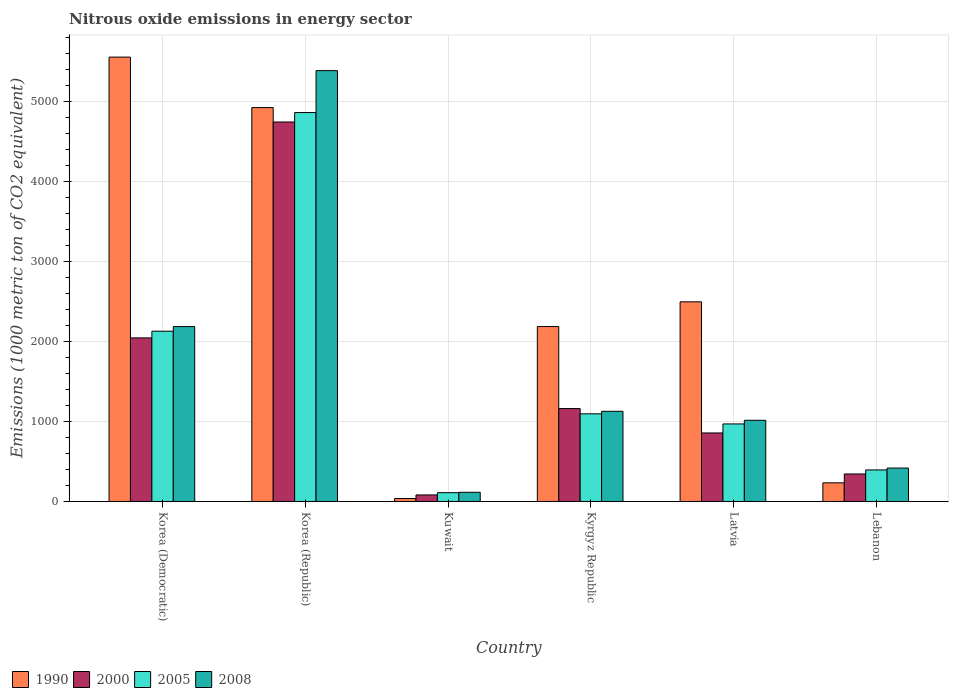How many groups of bars are there?
Your answer should be compact. 6. Are the number of bars per tick equal to the number of legend labels?
Offer a terse response. Yes. Are the number of bars on each tick of the X-axis equal?
Offer a very short reply. Yes. How many bars are there on the 1st tick from the right?
Give a very brief answer. 4. What is the label of the 4th group of bars from the left?
Your answer should be compact. Kyrgyz Republic. In how many cases, is the number of bars for a given country not equal to the number of legend labels?
Your answer should be compact. 0. What is the amount of nitrous oxide emitted in 1990 in Kyrgyz Republic?
Keep it short and to the point. 2188.3. Across all countries, what is the maximum amount of nitrous oxide emitted in 2008?
Offer a terse response. 5389.6. Across all countries, what is the minimum amount of nitrous oxide emitted in 2008?
Provide a short and direct response. 114.9. In which country was the amount of nitrous oxide emitted in 1990 maximum?
Make the answer very short. Korea (Democratic). In which country was the amount of nitrous oxide emitted in 2008 minimum?
Offer a very short reply. Kuwait. What is the total amount of nitrous oxide emitted in 2008 in the graph?
Offer a terse response. 1.03e+04. What is the difference between the amount of nitrous oxide emitted in 2000 in Latvia and that in Lebanon?
Provide a succinct answer. 512.9. What is the difference between the amount of nitrous oxide emitted in 2005 in Korea (Democratic) and the amount of nitrous oxide emitted in 1990 in Lebanon?
Provide a succinct answer. 1896.9. What is the average amount of nitrous oxide emitted in 1990 per country?
Ensure brevity in your answer.  2573.62. What is the difference between the amount of nitrous oxide emitted of/in 1990 and amount of nitrous oxide emitted of/in 2005 in Korea (Democratic)?
Offer a terse response. 3428.6. In how many countries, is the amount of nitrous oxide emitted in 2000 greater than 5400 1000 metric ton?
Provide a succinct answer. 0. What is the ratio of the amount of nitrous oxide emitted in 2000 in Kuwait to that in Lebanon?
Your answer should be very brief. 0.24. Is the difference between the amount of nitrous oxide emitted in 1990 in Kuwait and Kyrgyz Republic greater than the difference between the amount of nitrous oxide emitted in 2005 in Kuwait and Kyrgyz Republic?
Your answer should be very brief. No. What is the difference between the highest and the second highest amount of nitrous oxide emitted in 2005?
Your answer should be very brief. -3768.6. What is the difference between the highest and the lowest amount of nitrous oxide emitted in 2000?
Provide a succinct answer. 4664.9. In how many countries, is the amount of nitrous oxide emitted in 2000 greater than the average amount of nitrous oxide emitted in 2000 taken over all countries?
Your response must be concise. 2. Is it the case that in every country, the sum of the amount of nitrous oxide emitted in 1990 and amount of nitrous oxide emitted in 2000 is greater than the sum of amount of nitrous oxide emitted in 2005 and amount of nitrous oxide emitted in 2008?
Keep it short and to the point. No. What does the 1st bar from the left in Latvia represents?
Your response must be concise. 1990. What does the 3rd bar from the right in Latvia represents?
Offer a terse response. 2000. How many bars are there?
Offer a terse response. 24. How many countries are there in the graph?
Offer a terse response. 6. Does the graph contain any zero values?
Your response must be concise. No. Does the graph contain grids?
Make the answer very short. Yes. How are the legend labels stacked?
Make the answer very short. Horizontal. What is the title of the graph?
Your answer should be very brief. Nitrous oxide emissions in energy sector. Does "2011" appear as one of the legend labels in the graph?
Offer a terse response. No. What is the label or title of the Y-axis?
Keep it short and to the point. Emissions (1000 metric ton of CO2 equivalent). What is the Emissions (1000 metric ton of CO2 equivalent) in 1990 in Korea (Democratic)?
Your answer should be very brief. 5558.7. What is the Emissions (1000 metric ton of CO2 equivalent) of 2000 in Korea (Democratic)?
Your answer should be very brief. 2046.4. What is the Emissions (1000 metric ton of CO2 equivalent) in 2005 in Korea (Democratic)?
Your answer should be compact. 2130.1. What is the Emissions (1000 metric ton of CO2 equivalent) of 2008 in Korea (Democratic)?
Provide a short and direct response. 2187.5. What is the Emissions (1000 metric ton of CO2 equivalent) in 1990 in Korea (Republic)?
Make the answer very short. 4927.4. What is the Emissions (1000 metric ton of CO2 equivalent) in 2000 in Korea (Republic)?
Your answer should be very brief. 4746.8. What is the Emissions (1000 metric ton of CO2 equivalent) of 2005 in Korea (Republic)?
Ensure brevity in your answer.  4865. What is the Emissions (1000 metric ton of CO2 equivalent) in 2008 in Korea (Republic)?
Make the answer very short. 5389.6. What is the Emissions (1000 metric ton of CO2 equivalent) of 1990 in Kuwait?
Make the answer very short. 36.7. What is the Emissions (1000 metric ton of CO2 equivalent) in 2000 in Kuwait?
Ensure brevity in your answer.  81.9. What is the Emissions (1000 metric ton of CO2 equivalent) of 2005 in Kuwait?
Keep it short and to the point. 109.8. What is the Emissions (1000 metric ton of CO2 equivalent) in 2008 in Kuwait?
Offer a very short reply. 114.9. What is the Emissions (1000 metric ton of CO2 equivalent) in 1990 in Kyrgyz Republic?
Provide a short and direct response. 2188.3. What is the Emissions (1000 metric ton of CO2 equivalent) of 2000 in Kyrgyz Republic?
Provide a succinct answer. 1162.4. What is the Emissions (1000 metric ton of CO2 equivalent) in 2005 in Kyrgyz Republic?
Ensure brevity in your answer.  1096.4. What is the Emissions (1000 metric ton of CO2 equivalent) in 2008 in Kyrgyz Republic?
Offer a terse response. 1127.9. What is the Emissions (1000 metric ton of CO2 equivalent) of 1990 in Latvia?
Ensure brevity in your answer.  2497.4. What is the Emissions (1000 metric ton of CO2 equivalent) of 2000 in Latvia?
Your response must be concise. 857.1. What is the Emissions (1000 metric ton of CO2 equivalent) of 2005 in Latvia?
Ensure brevity in your answer.  970. What is the Emissions (1000 metric ton of CO2 equivalent) in 2008 in Latvia?
Your answer should be very brief. 1015.5. What is the Emissions (1000 metric ton of CO2 equivalent) in 1990 in Lebanon?
Provide a short and direct response. 233.2. What is the Emissions (1000 metric ton of CO2 equivalent) in 2000 in Lebanon?
Keep it short and to the point. 344.2. What is the Emissions (1000 metric ton of CO2 equivalent) of 2005 in Lebanon?
Provide a succinct answer. 394.7. What is the Emissions (1000 metric ton of CO2 equivalent) in 2008 in Lebanon?
Ensure brevity in your answer.  418.1. Across all countries, what is the maximum Emissions (1000 metric ton of CO2 equivalent) in 1990?
Provide a short and direct response. 5558.7. Across all countries, what is the maximum Emissions (1000 metric ton of CO2 equivalent) of 2000?
Your answer should be very brief. 4746.8. Across all countries, what is the maximum Emissions (1000 metric ton of CO2 equivalent) of 2005?
Make the answer very short. 4865. Across all countries, what is the maximum Emissions (1000 metric ton of CO2 equivalent) in 2008?
Your answer should be compact. 5389.6. Across all countries, what is the minimum Emissions (1000 metric ton of CO2 equivalent) in 1990?
Your answer should be very brief. 36.7. Across all countries, what is the minimum Emissions (1000 metric ton of CO2 equivalent) of 2000?
Provide a succinct answer. 81.9. Across all countries, what is the minimum Emissions (1000 metric ton of CO2 equivalent) of 2005?
Give a very brief answer. 109.8. Across all countries, what is the minimum Emissions (1000 metric ton of CO2 equivalent) of 2008?
Your answer should be compact. 114.9. What is the total Emissions (1000 metric ton of CO2 equivalent) of 1990 in the graph?
Make the answer very short. 1.54e+04. What is the total Emissions (1000 metric ton of CO2 equivalent) of 2000 in the graph?
Keep it short and to the point. 9238.8. What is the total Emissions (1000 metric ton of CO2 equivalent) in 2005 in the graph?
Keep it short and to the point. 9566. What is the total Emissions (1000 metric ton of CO2 equivalent) of 2008 in the graph?
Offer a very short reply. 1.03e+04. What is the difference between the Emissions (1000 metric ton of CO2 equivalent) in 1990 in Korea (Democratic) and that in Korea (Republic)?
Make the answer very short. 631.3. What is the difference between the Emissions (1000 metric ton of CO2 equivalent) in 2000 in Korea (Democratic) and that in Korea (Republic)?
Provide a succinct answer. -2700.4. What is the difference between the Emissions (1000 metric ton of CO2 equivalent) of 2005 in Korea (Democratic) and that in Korea (Republic)?
Your response must be concise. -2734.9. What is the difference between the Emissions (1000 metric ton of CO2 equivalent) of 2008 in Korea (Democratic) and that in Korea (Republic)?
Ensure brevity in your answer.  -3202.1. What is the difference between the Emissions (1000 metric ton of CO2 equivalent) of 1990 in Korea (Democratic) and that in Kuwait?
Give a very brief answer. 5522. What is the difference between the Emissions (1000 metric ton of CO2 equivalent) in 2000 in Korea (Democratic) and that in Kuwait?
Your answer should be compact. 1964.5. What is the difference between the Emissions (1000 metric ton of CO2 equivalent) of 2005 in Korea (Democratic) and that in Kuwait?
Ensure brevity in your answer.  2020.3. What is the difference between the Emissions (1000 metric ton of CO2 equivalent) of 2008 in Korea (Democratic) and that in Kuwait?
Your response must be concise. 2072.6. What is the difference between the Emissions (1000 metric ton of CO2 equivalent) in 1990 in Korea (Democratic) and that in Kyrgyz Republic?
Provide a short and direct response. 3370.4. What is the difference between the Emissions (1000 metric ton of CO2 equivalent) of 2000 in Korea (Democratic) and that in Kyrgyz Republic?
Provide a short and direct response. 884. What is the difference between the Emissions (1000 metric ton of CO2 equivalent) of 2005 in Korea (Democratic) and that in Kyrgyz Republic?
Provide a succinct answer. 1033.7. What is the difference between the Emissions (1000 metric ton of CO2 equivalent) in 2008 in Korea (Democratic) and that in Kyrgyz Republic?
Keep it short and to the point. 1059.6. What is the difference between the Emissions (1000 metric ton of CO2 equivalent) in 1990 in Korea (Democratic) and that in Latvia?
Provide a short and direct response. 3061.3. What is the difference between the Emissions (1000 metric ton of CO2 equivalent) in 2000 in Korea (Democratic) and that in Latvia?
Provide a short and direct response. 1189.3. What is the difference between the Emissions (1000 metric ton of CO2 equivalent) of 2005 in Korea (Democratic) and that in Latvia?
Give a very brief answer. 1160.1. What is the difference between the Emissions (1000 metric ton of CO2 equivalent) of 2008 in Korea (Democratic) and that in Latvia?
Keep it short and to the point. 1172. What is the difference between the Emissions (1000 metric ton of CO2 equivalent) of 1990 in Korea (Democratic) and that in Lebanon?
Your answer should be very brief. 5325.5. What is the difference between the Emissions (1000 metric ton of CO2 equivalent) of 2000 in Korea (Democratic) and that in Lebanon?
Your answer should be very brief. 1702.2. What is the difference between the Emissions (1000 metric ton of CO2 equivalent) of 2005 in Korea (Democratic) and that in Lebanon?
Your answer should be compact. 1735.4. What is the difference between the Emissions (1000 metric ton of CO2 equivalent) in 2008 in Korea (Democratic) and that in Lebanon?
Keep it short and to the point. 1769.4. What is the difference between the Emissions (1000 metric ton of CO2 equivalent) of 1990 in Korea (Republic) and that in Kuwait?
Offer a terse response. 4890.7. What is the difference between the Emissions (1000 metric ton of CO2 equivalent) in 2000 in Korea (Republic) and that in Kuwait?
Offer a very short reply. 4664.9. What is the difference between the Emissions (1000 metric ton of CO2 equivalent) of 2005 in Korea (Republic) and that in Kuwait?
Make the answer very short. 4755.2. What is the difference between the Emissions (1000 metric ton of CO2 equivalent) in 2008 in Korea (Republic) and that in Kuwait?
Offer a terse response. 5274.7. What is the difference between the Emissions (1000 metric ton of CO2 equivalent) of 1990 in Korea (Republic) and that in Kyrgyz Republic?
Provide a short and direct response. 2739.1. What is the difference between the Emissions (1000 metric ton of CO2 equivalent) of 2000 in Korea (Republic) and that in Kyrgyz Republic?
Keep it short and to the point. 3584.4. What is the difference between the Emissions (1000 metric ton of CO2 equivalent) of 2005 in Korea (Republic) and that in Kyrgyz Republic?
Keep it short and to the point. 3768.6. What is the difference between the Emissions (1000 metric ton of CO2 equivalent) of 2008 in Korea (Republic) and that in Kyrgyz Republic?
Offer a terse response. 4261.7. What is the difference between the Emissions (1000 metric ton of CO2 equivalent) in 1990 in Korea (Republic) and that in Latvia?
Keep it short and to the point. 2430. What is the difference between the Emissions (1000 metric ton of CO2 equivalent) of 2000 in Korea (Republic) and that in Latvia?
Your answer should be compact. 3889.7. What is the difference between the Emissions (1000 metric ton of CO2 equivalent) of 2005 in Korea (Republic) and that in Latvia?
Your answer should be very brief. 3895. What is the difference between the Emissions (1000 metric ton of CO2 equivalent) of 2008 in Korea (Republic) and that in Latvia?
Give a very brief answer. 4374.1. What is the difference between the Emissions (1000 metric ton of CO2 equivalent) in 1990 in Korea (Republic) and that in Lebanon?
Provide a short and direct response. 4694.2. What is the difference between the Emissions (1000 metric ton of CO2 equivalent) of 2000 in Korea (Republic) and that in Lebanon?
Ensure brevity in your answer.  4402.6. What is the difference between the Emissions (1000 metric ton of CO2 equivalent) of 2005 in Korea (Republic) and that in Lebanon?
Keep it short and to the point. 4470.3. What is the difference between the Emissions (1000 metric ton of CO2 equivalent) of 2008 in Korea (Republic) and that in Lebanon?
Your response must be concise. 4971.5. What is the difference between the Emissions (1000 metric ton of CO2 equivalent) in 1990 in Kuwait and that in Kyrgyz Republic?
Your response must be concise. -2151.6. What is the difference between the Emissions (1000 metric ton of CO2 equivalent) in 2000 in Kuwait and that in Kyrgyz Republic?
Provide a short and direct response. -1080.5. What is the difference between the Emissions (1000 metric ton of CO2 equivalent) of 2005 in Kuwait and that in Kyrgyz Republic?
Keep it short and to the point. -986.6. What is the difference between the Emissions (1000 metric ton of CO2 equivalent) of 2008 in Kuwait and that in Kyrgyz Republic?
Your answer should be very brief. -1013. What is the difference between the Emissions (1000 metric ton of CO2 equivalent) in 1990 in Kuwait and that in Latvia?
Ensure brevity in your answer.  -2460.7. What is the difference between the Emissions (1000 metric ton of CO2 equivalent) in 2000 in Kuwait and that in Latvia?
Ensure brevity in your answer.  -775.2. What is the difference between the Emissions (1000 metric ton of CO2 equivalent) in 2005 in Kuwait and that in Latvia?
Give a very brief answer. -860.2. What is the difference between the Emissions (1000 metric ton of CO2 equivalent) of 2008 in Kuwait and that in Latvia?
Offer a very short reply. -900.6. What is the difference between the Emissions (1000 metric ton of CO2 equivalent) in 1990 in Kuwait and that in Lebanon?
Offer a terse response. -196.5. What is the difference between the Emissions (1000 metric ton of CO2 equivalent) of 2000 in Kuwait and that in Lebanon?
Ensure brevity in your answer.  -262.3. What is the difference between the Emissions (1000 metric ton of CO2 equivalent) of 2005 in Kuwait and that in Lebanon?
Ensure brevity in your answer.  -284.9. What is the difference between the Emissions (1000 metric ton of CO2 equivalent) in 2008 in Kuwait and that in Lebanon?
Your answer should be compact. -303.2. What is the difference between the Emissions (1000 metric ton of CO2 equivalent) of 1990 in Kyrgyz Republic and that in Latvia?
Ensure brevity in your answer.  -309.1. What is the difference between the Emissions (1000 metric ton of CO2 equivalent) in 2000 in Kyrgyz Republic and that in Latvia?
Ensure brevity in your answer.  305.3. What is the difference between the Emissions (1000 metric ton of CO2 equivalent) in 2005 in Kyrgyz Republic and that in Latvia?
Give a very brief answer. 126.4. What is the difference between the Emissions (1000 metric ton of CO2 equivalent) of 2008 in Kyrgyz Republic and that in Latvia?
Make the answer very short. 112.4. What is the difference between the Emissions (1000 metric ton of CO2 equivalent) in 1990 in Kyrgyz Republic and that in Lebanon?
Give a very brief answer. 1955.1. What is the difference between the Emissions (1000 metric ton of CO2 equivalent) in 2000 in Kyrgyz Republic and that in Lebanon?
Make the answer very short. 818.2. What is the difference between the Emissions (1000 metric ton of CO2 equivalent) of 2005 in Kyrgyz Republic and that in Lebanon?
Keep it short and to the point. 701.7. What is the difference between the Emissions (1000 metric ton of CO2 equivalent) in 2008 in Kyrgyz Republic and that in Lebanon?
Give a very brief answer. 709.8. What is the difference between the Emissions (1000 metric ton of CO2 equivalent) of 1990 in Latvia and that in Lebanon?
Provide a succinct answer. 2264.2. What is the difference between the Emissions (1000 metric ton of CO2 equivalent) of 2000 in Latvia and that in Lebanon?
Ensure brevity in your answer.  512.9. What is the difference between the Emissions (1000 metric ton of CO2 equivalent) of 2005 in Latvia and that in Lebanon?
Offer a very short reply. 575.3. What is the difference between the Emissions (1000 metric ton of CO2 equivalent) of 2008 in Latvia and that in Lebanon?
Provide a succinct answer. 597.4. What is the difference between the Emissions (1000 metric ton of CO2 equivalent) of 1990 in Korea (Democratic) and the Emissions (1000 metric ton of CO2 equivalent) of 2000 in Korea (Republic)?
Give a very brief answer. 811.9. What is the difference between the Emissions (1000 metric ton of CO2 equivalent) in 1990 in Korea (Democratic) and the Emissions (1000 metric ton of CO2 equivalent) in 2005 in Korea (Republic)?
Provide a short and direct response. 693.7. What is the difference between the Emissions (1000 metric ton of CO2 equivalent) of 1990 in Korea (Democratic) and the Emissions (1000 metric ton of CO2 equivalent) of 2008 in Korea (Republic)?
Provide a succinct answer. 169.1. What is the difference between the Emissions (1000 metric ton of CO2 equivalent) of 2000 in Korea (Democratic) and the Emissions (1000 metric ton of CO2 equivalent) of 2005 in Korea (Republic)?
Offer a terse response. -2818.6. What is the difference between the Emissions (1000 metric ton of CO2 equivalent) in 2000 in Korea (Democratic) and the Emissions (1000 metric ton of CO2 equivalent) in 2008 in Korea (Republic)?
Offer a very short reply. -3343.2. What is the difference between the Emissions (1000 metric ton of CO2 equivalent) of 2005 in Korea (Democratic) and the Emissions (1000 metric ton of CO2 equivalent) of 2008 in Korea (Republic)?
Offer a terse response. -3259.5. What is the difference between the Emissions (1000 metric ton of CO2 equivalent) of 1990 in Korea (Democratic) and the Emissions (1000 metric ton of CO2 equivalent) of 2000 in Kuwait?
Keep it short and to the point. 5476.8. What is the difference between the Emissions (1000 metric ton of CO2 equivalent) in 1990 in Korea (Democratic) and the Emissions (1000 metric ton of CO2 equivalent) in 2005 in Kuwait?
Offer a terse response. 5448.9. What is the difference between the Emissions (1000 metric ton of CO2 equivalent) in 1990 in Korea (Democratic) and the Emissions (1000 metric ton of CO2 equivalent) in 2008 in Kuwait?
Ensure brevity in your answer.  5443.8. What is the difference between the Emissions (1000 metric ton of CO2 equivalent) of 2000 in Korea (Democratic) and the Emissions (1000 metric ton of CO2 equivalent) of 2005 in Kuwait?
Provide a succinct answer. 1936.6. What is the difference between the Emissions (1000 metric ton of CO2 equivalent) of 2000 in Korea (Democratic) and the Emissions (1000 metric ton of CO2 equivalent) of 2008 in Kuwait?
Your answer should be compact. 1931.5. What is the difference between the Emissions (1000 metric ton of CO2 equivalent) in 2005 in Korea (Democratic) and the Emissions (1000 metric ton of CO2 equivalent) in 2008 in Kuwait?
Your answer should be compact. 2015.2. What is the difference between the Emissions (1000 metric ton of CO2 equivalent) in 1990 in Korea (Democratic) and the Emissions (1000 metric ton of CO2 equivalent) in 2000 in Kyrgyz Republic?
Offer a terse response. 4396.3. What is the difference between the Emissions (1000 metric ton of CO2 equivalent) of 1990 in Korea (Democratic) and the Emissions (1000 metric ton of CO2 equivalent) of 2005 in Kyrgyz Republic?
Provide a succinct answer. 4462.3. What is the difference between the Emissions (1000 metric ton of CO2 equivalent) in 1990 in Korea (Democratic) and the Emissions (1000 metric ton of CO2 equivalent) in 2008 in Kyrgyz Republic?
Your answer should be very brief. 4430.8. What is the difference between the Emissions (1000 metric ton of CO2 equivalent) in 2000 in Korea (Democratic) and the Emissions (1000 metric ton of CO2 equivalent) in 2005 in Kyrgyz Republic?
Your answer should be compact. 950. What is the difference between the Emissions (1000 metric ton of CO2 equivalent) in 2000 in Korea (Democratic) and the Emissions (1000 metric ton of CO2 equivalent) in 2008 in Kyrgyz Republic?
Provide a succinct answer. 918.5. What is the difference between the Emissions (1000 metric ton of CO2 equivalent) of 2005 in Korea (Democratic) and the Emissions (1000 metric ton of CO2 equivalent) of 2008 in Kyrgyz Republic?
Ensure brevity in your answer.  1002.2. What is the difference between the Emissions (1000 metric ton of CO2 equivalent) in 1990 in Korea (Democratic) and the Emissions (1000 metric ton of CO2 equivalent) in 2000 in Latvia?
Provide a succinct answer. 4701.6. What is the difference between the Emissions (1000 metric ton of CO2 equivalent) in 1990 in Korea (Democratic) and the Emissions (1000 metric ton of CO2 equivalent) in 2005 in Latvia?
Your response must be concise. 4588.7. What is the difference between the Emissions (1000 metric ton of CO2 equivalent) of 1990 in Korea (Democratic) and the Emissions (1000 metric ton of CO2 equivalent) of 2008 in Latvia?
Offer a terse response. 4543.2. What is the difference between the Emissions (1000 metric ton of CO2 equivalent) of 2000 in Korea (Democratic) and the Emissions (1000 metric ton of CO2 equivalent) of 2005 in Latvia?
Give a very brief answer. 1076.4. What is the difference between the Emissions (1000 metric ton of CO2 equivalent) of 2000 in Korea (Democratic) and the Emissions (1000 metric ton of CO2 equivalent) of 2008 in Latvia?
Keep it short and to the point. 1030.9. What is the difference between the Emissions (1000 metric ton of CO2 equivalent) of 2005 in Korea (Democratic) and the Emissions (1000 metric ton of CO2 equivalent) of 2008 in Latvia?
Offer a very short reply. 1114.6. What is the difference between the Emissions (1000 metric ton of CO2 equivalent) in 1990 in Korea (Democratic) and the Emissions (1000 metric ton of CO2 equivalent) in 2000 in Lebanon?
Ensure brevity in your answer.  5214.5. What is the difference between the Emissions (1000 metric ton of CO2 equivalent) in 1990 in Korea (Democratic) and the Emissions (1000 metric ton of CO2 equivalent) in 2005 in Lebanon?
Give a very brief answer. 5164. What is the difference between the Emissions (1000 metric ton of CO2 equivalent) in 1990 in Korea (Democratic) and the Emissions (1000 metric ton of CO2 equivalent) in 2008 in Lebanon?
Offer a terse response. 5140.6. What is the difference between the Emissions (1000 metric ton of CO2 equivalent) of 2000 in Korea (Democratic) and the Emissions (1000 metric ton of CO2 equivalent) of 2005 in Lebanon?
Offer a terse response. 1651.7. What is the difference between the Emissions (1000 metric ton of CO2 equivalent) of 2000 in Korea (Democratic) and the Emissions (1000 metric ton of CO2 equivalent) of 2008 in Lebanon?
Provide a succinct answer. 1628.3. What is the difference between the Emissions (1000 metric ton of CO2 equivalent) in 2005 in Korea (Democratic) and the Emissions (1000 metric ton of CO2 equivalent) in 2008 in Lebanon?
Give a very brief answer. 1712. What is the difference between the Emissions (1000 metric ton of CO2 equivalent) of 1990 in Korea (Republic) and the Emissions (1000 metric ton of CO2 equivalent) of 2000 in Kuwait?
Your response must be concise. 4845.5. What is the difference between the Emissions (1000 metric ton of CO2 equivalent) in 1990 in Korea (Republic) and the Emissions (1000 metric ton of CO2 equivalent) in 2005 in Kuwait?
Provide a succinct answer. 4817.6. What is the difference between the Emissions (1000 metric ton of CO2 equivalent) in 1990 in Korea (Republic) and the Emissions (1000 metric ton of CO2 equivalent) in 2008 in Kuwait?
Your answer should be very brief. 4812.5. What is the difference between the Emissions (1000 metric ton of CO2 equivalent) in 2000 in Korea (Republic) and the Emissions (1000 metric ton of CO2 equivalent) in 2005 in Kuwait?
Make the answer very short. 4637. What is the difference between the Emissions (1000 metric ton of CO2 equivalent) of 2000 in Korea (Republic) and the Emissions (1000 metric ton of CO2 equivalent) of 2008 in Kuwait?
Make the answer very short. 4631.9. What is the difference between the Emissions (1000 metric ton of CO2 equivalent) of 2005 in Korea (Republic) and the Emissions (1000 metric ton of CO2 equivalent) of 2008 in Kuwait?
Your response must be concise. 4750.1. What is the difference between the Emissions (1000 metric ton of CO2 equivalent) of 1990 in Korea (Republic) and the Emissions (1000 metric ton of CO2 equivalent) of 2000 in Kyrgyz Republic?
Provide a succinct answer. 3765. What is the difference between the Emissions (1000 metric ton of CO2 equivalent) in 1990 in Korea (Republic) and the Emissions (1000 metric ton of CO2 equivalent) in 2005 in Kyrgyz Republic?
Ensure brevity in your answer.  3831. What is the difference between the Emissions (1000 metric ton of CO2 equivalent) of 1990 in Korea (Republic) and the Emissions (1000 metric ton of CO2 equivalent) of 2008 in Kyrgyz Republic?
Give a very brief answer. 3799.5. What is the difference between the Emissions (1000 metric ton of CO2 equivalent) of 2000 in Korea (Republic) and the Emissions (1000 metric ton of CO2 equivalent) of 2005 in Kyrgyz Republic?
Offer a very short reply. 3650.4. What is the difference between the Emissions (1000 metric ton of CO2 equivalent) of 2000 in Korea (Republic) and the Emissions (1000 metric ton of CO2 equivalent) of 2008 in Kyrgyz Republic?
Offer a terse response. 3618.9. What is the difference between the Emissions (1000 metric ton of CO2 equivalent) in 2005 in Korea (Republic) and the Emissions (1000 metric ton of CO2 equivalent) in 2008 in Kyrgyz Republic?
Your answer should be very brief. 3737.1. What is the difference between the Emissions (1000 metric ton of CO2 equivalent) in 1990 in Korea (Republic) and the Emissions (1000 metric ton of CO2 equivalent) in 2000 in Latvia?
Offer a terse response. 4070.3. What is the difference between the Emissions (1000 metric ton of CO2 equivalent) of 1990 in Korea (Republic) and the Emissions (1000 metric ton of CO2 equivalent) of 2005 in Latvia?
Offer a very short reply. 3957.4. What is the difference between the Emissions (1000 metric ton of CO2 equivalent) of 1990 in Korea (Republic) and the Emissions (1000 metric ton of CO2 equivalent) of 2008 in Latvia?
Provide a short and direct response. 3911.9. What is the difference between the Emissions (1000 metric ton of CO2 equivalent) of 2000 in Korea (Republic) and the Emissions (1000 metric ton of CO2 equivalent) of 2005 in Latvia?
Make the answer very short. 3776.8. What is the difference between the Emissions (1000 metric ton of CO2 equivalent) of 2000 in Korea (Republic) and the Emissions (1000 metric ton of CO2 equivalent) of 2008 in Latvia?
Provide a short and direct response. 3731.3. What is the difference between the Emissions (1000 metric ton of CO2 equivalent) in 2005 in Korea (Republic) and the Emissions (1000 metric ton of CO2 equivalent) in 2008 in Latvia?
Make the answer very short. 3849.5. What is the difference between the Emissions (1000 metric ton of CO2 equivalent) of 1990 in Korea (Republic) and the Emissions (1000 metric ton of CO2 equivalent) of 2000 in Lebanon?
Keep it short and to the point. 4583.2. What is the difference between the Emissions (1000 metric ton of CO2 equivalent) of 1990 in Korea (Republic) and the Emissions (1000 metric ton of CO2 equivalent) of 2005 in Lebanon?
Make the answer very short. 4532.7. What is the difference between the Emissions (1000 metric ton of CO2 equivalent) in 1990 in Korea (Republic) and the Emissions (1000 metric ton of CO2 equivalent) in 2008 in Lebanon?
Ensure brevity in your answer.  4509.3. What is the difference between the Emissions (1000 metric ton of CO2 equivalent) of 2000 in Korea (Republic) and the Emissions (1000 metric ton of CO2 equivalent) of 2005 in Lebanon?
Ensure brevity in your answer.  4352.1. What is the difference between the Emissions (1000 metric ton of CO2 equivalent) in 2000 in Korea (Republic) and the Emissions (1000 metric ton of CO2 equivalent) in 2008 in Lebanon?
Your answer should be very brief. 4328.7. What is the difference between the Emissions (1000 metric ton of CO2 equivalent) in 2005 in Korea (Republic) and the Emissions (1000 metric ton of CO2 equivalent) in 2008 in Lebanon?
Your answer should be compact. 4446.9. What is the difference between the Emissions (1000 metric ton of CO2 equivalent) of 1990 in Kuwait and the Emissions (1000 metric ton of CO2 equivalent) of 2000 in Kyrgyz Republic?
Provide a succinct answer. -1125.7. What is the difference between the Emissions (1000 metric ton of CO2 equivalent) in 1990 in Kuwait and the Emissions (1000 metric ton of CO2 equivalent) in 2005 in Kyrgyz Republic?
Offer a very short reply. -1059.7. What is the difference between the Emissions (1000 metric ton of CO2 equivalent) in 1990 in Kuwait and the Emissions (1000 metric ton of CO2 equivalent) in 2008 in Kyrgyz Republic?
Your answer should be compact. -1091.2. What is the difference between the Emissions (1000 metric ton of CO2 equivalent) of 2000 in Kuwait and the Emissions (1000 metric ton of CO2 equivalent) of 2005 in Kyrgyz Republic?
Make the answer very short. -1014.5. What is the difference between the Emissions (1000 metric ton of CO2 equivalent) of 2000 in Kuwait and the Emissions (1000 metric ton of CO2 equivalent) of 2008 in Kyrgyz Republic?
Keep it short and to the point. -1046. What is the difference between the Emissions (1000 metric ton of CO2 equivalent) of 2005 in Kuwait and the Emissions (1000 metric ton of CO2 equivalent) of 2008 in Kyrgyz Republic?
Make the answer very short. -1018.1. What is the difference between the Emissions (1000 metric ton of CO2 equivalent) in 1990 in Kuwait and the Emissions (1000 metric ton of CO2 equivalent) in 2000 in Latvia?
Your answer should be very brief. -820.4. What is the difference between the Emissions (1000 metric ton of CO2 equivalent) in 1990 in Kuwait and the Emissions (1000 metric ton of CO2 equivalent) in 2005 in Latvia?
Your answer should be very brief. -933.3. What is the difference between the Emissions (1000 metric ton of CO2 equivalent) in 1990 in Kuwait and the Emissions (1000 metric ton of CO2 equivalent) in 2008 in Latvia?
Your response must be concise. -978.8. What is the difference between the Emissions (1000 metric ton of CO2 equivalent) of 2000 in Kuwait and the Emissions (1000 metric ton of CO2 equivalent) of 2005 in Latvia?
Provide a short and direct response. -888.1. What is the difference between the Emissions (1000 metric ton of CO2 equivalent) in 2000 in Kuwait and the Emissions (1000 metric ton of CO2 equivalent) in 2008 in Latvia?
Your response must be concise. -933.6. What is the difference between the Emissions (1000 metric ton of CO2 equivalent) of 2005 in Kuwait and the Emissions (1000 metric ton of CO2 equivalent) of 2008 in Latvia?
Make the answer very short. -905.7. What is the difference between the Emissions (1000 metric ton of CO2 equivalent) of 1990 in Kuwait and the Emissions (1000 metric ton of CO2 equivalent) of 2000 in Lebanon?
Keep it short and to the point. -307.5. What is the difference between the Emissions (1000 metric ton of CO2 equivalent) of 1990 in Kuwait and the Emissions (1000 metric ton of CO2 equivalent) of 2005 in Lebanon?
Keep it short and to the point. -358. What is the difference between the Emissions (1000 metric ton of CO2 equivalent) in 1990 in Kuwait and the Emissions (1000 metric ton of CO2 equivalent) in 2008 in Lebanon?
Offer a very short reply. -381.4. What is the difference between the Emissions (1000 metric ton of CO2 equivalent) in 2000 in Kuwait and the Emissions (1000 metric ton of CO2 equivalent) in 2005 in Lebanon?
Make the answer very short. -312.8. What is the difference between the Emissions (1000 metric ton of CO2 equivalent) of 2000 in Kuwait and the Emissions (1000 metric ton of CO2 equivalent) of 2008 in Lebanon?
Provide a succinct answer. -336.2. What is the difference between the Emissions (1000 metric ton of CO2 equivalent) in 2005 in Kuwait and the Emissions (1000 metric ton of CO2 equivalent) in 2008 in Lebanon?
Offer a very short reply. -308.3. What is the difference between the Emissions (1000 metric ton of CO2 equivalent) in 1990 in Kyrgyz Republic and the Emissions (1000 metric ton of CO2 equivalent) in 2000 in Latvia?
Keep it short and to the point. 1331.2. What is the difference between the Emissions (1000 metric ton of CO2 equivalent) in 1990 in Kyrgyz Republic and the Emissions (1000 metric ton of CO2 equivalent) in 2005 in Latvia?
Provide a short and direct response. 1218.3. What is the difference between the Emissions (1000 metric ton of CO2 equivalent) in 1990 in Kyrgyz Republic and the Emissions (1000 metric ton of CO2 equivalent) in 2008 in Latvia?
Offer a very short reply. 1172.8. What is the difference between the Emissions (1000 metric ton of CO2 equivalent) of 2000 in Kyrgyz Republic and the Emissions (1000 metric ton of CO2 equivalent) of 2005 in Latvia?
Ensure brevity in your answer.  192.4. What is the difference between the Emissions (1000 metric ton of CO2 equivalent) of 2000 in Kyrgyz Republic and the Emissions (1000 metric ton of CO2 equivalent) of 2008 in Latvia?
Your answer should be compact. 146.9. What is the difference between the Emissions (1000 metric ton of CO2 equivalent) in 2005 in Kyrgyz Republic and the Emissions (1000 metric ton of CO2 equivalent) in 2008 in Latvia?
Your answer should be compact. 80.9. What is the difference between the Emissions (1000 metric ton of CO2 equivalent) in 1990 in Kyrgyz Republic and the Emissions (1000 metric ton of CO2 equivalent) in 2000 in Lebanon?
Make the answer very short. 1844.1. What is the difference between the Emissions (1000 metric ton of CO2 equivalent) of 1990 in Kyrgyz Republic and the Emissions (1000 metric ton of CO2 equivalent) of 2005 in Lebanon?
Your answer should be very brief. 1793.6. What is the difference between the Emissions (1000 metric ton of CO2 equivalent) of 1990 in Kyrgyz Republic and the Emissions (1000 metric ton of CO2 equivalent) of 2008 in Lebanon?
Provide a short and direct response. 1770.2. What is the difference between the Emissions (1000 metric ton of CO2 equivalent) of 2000 in Kyrgyz Republic and the Emissions (1000 metric ton of CO2 equivalent) of 2005 in Lebanon?
Offer a very short reply. 767.7. What is the difference between the Emissions (1000 metric ton of CO2 equivalent) of 2000 in Kyrgyz Republic and the Emissions (1000 metric ton of CO2 equivalent) of 2008 in Lebanon?
Make the answer very short. 744.3. What is the difference between the Emissions (1000 metric ton of CO2 equivalent) in 2005 in Kyrgyz Republic and the Emissions (1000 metric ton of CO2 equivalent) in 2008 in Lebanon?
Offer a very short reply. 678.3. What is the difference between the Emissions (1000 metric ton of CO2 equivalent) in 1990 in Latvia and the Emissions (1000 metric ton of CO2 equivalent) in 2000 in Lebanon?
Give a very brief answer. 2153.2. What is the difference between the Emissions (1000 metric ton of CO2 equivalent) of 1990 in Latvia and the Emissions (1000 metric ton of CO2 equivalent) of 2005 in Lebanon?
Provide a short and direct response. 2102.7. What is the difference between the Emissions (1000 metric ton of CO2 equivalent) in 1990 in Latvia and the Emissions (1000 metric ton of CO2 equivalent) in 2008 in Lebanon?
Your response must be concise. 2079.3. What is the difference between the Emissions (1000 metric ton of CO2 equivalent) of 2000 in Latvia and the Emissions (1000 metric ton of CO2 equivalent) of 2005 in Lebanon?
Your answer should be very brief. 462.4. What is the difference between the Emissions (1000 metric ton of CO2 equivalent) of 2000 in Latvia and the Emissions (1000 metric ton of CO2 equivalent) of 2008 in Lebanon?
Your response must be concise. 439. What is the difference between the Emissions (1000 metric ton of CO2 equivalent) of 2005 in Latvia and the Emissions (1000 metric ton of CO2 equivalent) of 2008 in Lebanon?
Offer a terse response. 551.9. What is the average Emissions (1000 metric ton of CO2 equivalent) of 1990 per country?
Your answer should be compact. 2573.62. What is the average Emissions (1000 metric ton of CO2 equivalent) of 2000 per country?
Ensure brevity in your answer.  1539.8. What is the average Emissions (1000 metric ton of CO2 equivalent) in 2005 per country?
Ensure brevity in your answer.  1594.33. What is the average Emissions (1000 metric ton of CO2 equivalent) of 2008 per country?
Make the answer very short. 1708.92. What is the difference between the Emissions (1000 metric ton of CO2 equivalent) in 1990 and Emissions (1000 metric ton of CO2 equivalent) in 2000 in Korea (Democratic)?
Your answer should be very brief. 3512.3. What is the difference between the Emissions (1000 metric ton of CO2 equivalent) in 1990 and Emissions (1000 metric ton of CO2 equivalent) in 2005 in Korea (Democratic)?
Your response must be concise. 3428.6. What is the difference between the Emissions (1000 metric ton of CO2 equivalent) of 1990 and Emissions (1000 metric ton of CO2 equivalent) of 2008 in Korea (Democratic)?
Your answer should be very brief. 3371.2. What is the difference between the Emissions (1000 metric ton of CO2 equivalent) of 2000 and Emissions (1000 metric ton of CO2 equivalent) of 2005 in Korea (Democratic)?
Ensure brevity in your answer.  -83.7. What is the difference between the Emissions (1000 metric ton of CO2 equivalent) in 2000 and Emissions (1000 metric ton of CO2 equivalent) in 2008 in Korea (Democratic)?
Offer a terse response. -141.1. What is the difference between the Emissions (1000 metric ton of CO2 equivalent) of 2005 and Emissions (1000 metric ton of CO2 equivalent) of 2008 in Korea (Democratic)?
Your answer should be very brief. -57.4. What is the difference between the Emissions (1000 metric ton of CO2 equivalent) of 1990 and Emissions (1000 metric ton of CO2 equivalent) of 2000 in Korea (Republic)?
Provide a succinct answer. 180.6. What is the difference between the Emissions (1000 metric ton of CO2 equivalent) in 1990 and Emissions (1000 metric ton of CO2 equivalent) in 2005 in Korea (Republic)?
Offer a very short reply. 62.4. What is the difference between the Emissions (1000 metric ton of CO2 equivalent) of 1990 and Emissions (1000 metric ton of CO2 equivalent) of 2008 in Korea (Republic)?
Ensure brevity in your answer.  -462.2. What is the difference between the Emissions (1000 metric ton of CO2 equivalent) of 2000 and Emissions (1000 metric ton of CO2 equivalent) of 2005 in Korea (Republic)?
Your response must be concise. -118.2. What is the difference between the Emissions (1000 metric ton of CO2 equivalent) of 2000 and Emissions (1000 metric ton of CO2 equivalent) of 2008 in Korea (Republic)?
Give a very brief answer. -642.8. What is the difference between the Emissions (1000 metric ton of CO2 equivalent) of 2005 and Emissions (1000 metric ton of CO2 equivalent) of 2008 in Korea (Republic)?
Your response must be concise. -524.6. What is the difference between the Emissions (1000 metric ton of CO2 equivalent) in 1990 and Emissions (1000 metric ton of CO2 equivalent) in 2000 in Kuwait?
Keep it short and to the point. -45.2. What is the difference between the Emissions (1000 metric ton of CO2 equivalent) in 1990 and Emissions (1000 metric ton of CO2 equivalent) in 2005 in Kuwait?
Provide a succinct answer. -73.1. What is the difference between the Emissions (1000 metric ton of CO2 equivalent) of 1990 and Emissions (1000 metric ton of CO2 equivalent) of 2008 in Kuwait?
Offer a terse response. -78.2. What is the difference between the Emissions (1000 metric ton of CO2 equivalent) in 2000 and Emissions (1000 metric ton of CO2 equivalent) in 2005 in Kuwait?
Offer a very short reply. -27.9. What is the difference between the Emissions (1000 metric ton of CO2 equivalent) in 2000 and Emissions (1000 metric ton of CO2 equivalent) in 2008 in Kuwait?
Offer a terse response. -33. What is the difference between the Emissions (1000 metric ton of CO2 equivalent) in 2005 and Emissions (1000 metric ton of CO2 equivalent) in 2008 in Kuwait?
Provide a short and direct response. -5.1. What is the difference between the Emissions (1000 metric ton of CO2 equivalent) of 1990 and Emissions (1000 metric ton of CO2 equivalent) of 2000 in Kyrgyz Republic?
Offer a very short reply. 1025.9. What is the difference between the Emissions (1000 metric ton of CO2 equivalent) of 1990 and Emissions (1000 metric ton of CO2 equivalent) of 2005 in Kyrgyz Republic?
Provide a short and direct response. 1091.9. What is the difference between the Emissions (1000 metric ton of CO2 equivalent) of 1990 and Emissions (1000 metric ton of CO2 equivalent) of 2008 in Kyrgyz Republic?
Ensure brevity in your answer.  1060.4. What is the difference between the Emissions (1000 metric ton of CO2 equivalent) of 2000 and Emissions (1000 metric ton of CO2 equivalent) of 2005 in Kyrgyz Republic?
Offer a very short reply. 66. What is the difference between the Emissions (1000 metric ton of CO2 equivalent) in 2000 and Emissions (1000 metric ton of CO2 equivalent) in 2008 in Kyrgyz Republic?
Provide a succinct answer. 34.5. What is the difference between the Emissions (1000 metric ton of CO2 equivalent) of 2005 and Emissions (1000 metric ton of CO2 equivalent) of 2008 in Kyrgyz Republic?
Ensure brevity in your answer.  -31.5. What is the difference between the Emissions (1000 metric ton of CO2 equivalent) of 1990 and Emissions (1000 metric ton of CO2 equivalent) of 2000 in Latvia?
Give a very brief answer. 1640.3. What is the difference between the Emissions (1000 metric ton of CO2 equivalent) in 1990 and Emissions (1000 metric ton of CO2 equivalent) in 2005 in Latvia?
Your response must be concise. 1527.4. What is the difference between the Emissions (1000 metric ton of CO2 equivalent) of 1990 and Emissions (1000 metric ton of CO2 equivalent) of 2008 in Latvia?
Your answer should be compact. 1481.9. What is the difference between the Emissions (1000 metric ton of CO2 equivalent) in 2000 and Emissions (1000 metric ton of CO2 equivalent) in 2005 in Latvia?
Make the answer very short. -112.9. What is the difference between the Emissions (1000 metric ton of CO2 equivalent) in 2000 and Emissions (1000 metric ton of CO2 equivalent) in 2008 in Latvia?
Provide a short and direct response. -158.4. What is the difference between the Emissions (1000 metric ton of CO2 equivalent) in 2005 and Emissions (1000 metric ton of CO2 equivalent) in 2008 in Latvia?
Your response must be concise. -45.5. What is the difference between the Emissions (1000 metric ton of CO2 equivalent) in 1990 and Emissions (1000 metric ton of CO2 equivalent) in 2000 in Lebanon?
Your response must be concise. -111. What is the difference between the Emissions (1000 metric ton of CO2 equivalent) in 1990 and Emissions (1000 metric ton of CO2 equivalent) in 2005 in Lebanon?
Provide a short and direct response. -161.5. What is the difference between the Emissions (1000 metric ton of CO2 equivalent) of 1990 and Emissions (1000 metric ton of CO2 equivalent) of 2008 in Lebanon?
Ensure brevity in your answer.  -184.9. What is the difference between the Emissions (1000 metric ton of CO2 equivalent) of 2000 and Emissions (1000 metric ton of CO2 equivalent) of 2005 in Lebanon?
Your answer should be very brief. -50.5. What is the difference between the Emissions (1000 metric ton of CO2 equivalent) in 2000 and Emissions (1000 metric ton of CO2 equivalent) in 2008 in Lebanon?
Your response must be concise. -73.9. What is the difference between the Emissions (1000 metric ton of CO2 equivalent) in 2005 and Emissions (1000 metric ton of CO2 equivalent) in 2008 in Lebanon?
Provide a short and direct response. -23.4. What is the ratio of the Emissions (1000 metric ton of CO2 equivalent) in 1990 in Korea (Democratic) to that in Korea (Republic)?
Give a very brief answer. 1.13. What is the ratio of the Emissions (1000 metric ton of CO2 equivalent) of 2000 in Korea (Democratic) to that in Korea (Republic)?
Your response must be concise. 0.43. What is the ratio of the Emissions (1000 metric ton of CO2 equivalent) of 2005 in Korea (Democratic) to that in Korea (Republic)?
Make the answer very short. 0.44. What is the ratio of the Emissions (1000 metric ton of CO2 equivalent) in 2008 in Korea (Democratic) to that in Korea (Republic)?
Your response must be concise. 0.41. What is the ratio of the Emissions (1000 metric ton of CO2 equivalent) in 1990 in Korea (Democratic) to that in Kuwait?
Provide a succinct answer. 151.46. What is the ratio of the Emissions (1000 metric ton of CO2 equivalent) in 2000 in Korea (Democratic) to that in Kuwait?
Ensure brevity in your answer.  24.99. What is the ratio of the Emissions (1000 metric ton of CO2 equivalent) of 2005 in Korea (Democratic) to that in Kuwait?
Offer a very short reply. 19.4. What is the ratio of the Emissions (1000 metric ton of CO2 equivalent) in 2008 in Korea (Democratic) to that in Kuwait?
Your answer should be compact. 19.04. What is the ratio of the Emissions (1000 metric ton of CO2 equivalent) of 1990 in Korea (Democratic) to that in Kyrgyz Republic?
Keep it short and to the point. 2.54. What is the ratio of the Emissions (1000 metric ton of CO2 equivalent) in 2000 in Korea (Democratic) to that in Kyrgyz Republic?
Your answer should be very brief. 1.76. What is the ratio of the Emissions (1000 metric ton of CO2 equivalent) of 2005 in Korea (Democratic) to that in Kyrgyz Republic?
Your response must be concise. 1.94. What is the ratio of the Emissions (1000 metric ton of CO2 equivalent) of 2008 in Korea (Democratic) to that in Kyrgyz Republic?
Ensure brevity in your answer.  1.94. What is the ratio of the Emissions (1000 metric ton of CO2 equivalent) of 1990 in Korea (Democratic) to that in Latvia?
Your answer should be very brief. 2.23. What is the ratio of the Emissions (1000 metric ton of CO2 equivalent) in 2000 in Korea (Democratic) to that in Latvia?
Make the answer very short. 2.39. What is the ratio of the Emissions (1000 metric ton of CO2 equivalent) in 2005 in Korea (Democratic) to that in Latvia?
Keep it short and to the point. 2.2. What is the ratio of the Emissions (1000 metric ton of CO2 equivalent) in 2008 in Korea (Democratic) to that in Latvia?
Offer a terse response. 2.15. What is the ratio of the Emissions (1000 metric ton of CO2 equivalent) in 1990 in Korea (Democratic) to that in Lebanon?
Give a very brief answer. 23.84. What is the ratio of the Emissions (1000 metric ton of CO2 equivalent) of 2000 in Korea (Democratic) to that in Lebanon?
Your answer should be compact. 5.95. What is the ratio of the Emissions (1000 metric ton of CO2 equivalent) in 2005 in Korea (Democratic) to that in Lebanon?
Ensure brevity in your answer.  5.4. What is the ratio of the Emissions (1000 metric ton of CO2 equivalent) of 2008 in Korea (Democratic) to that in Lebanon?
Your response must be concise. 5.23. What is the ratio of the Emissions (1000 metric ton of CO2 equivalent) in 1990 in Korea (Republic) to that in Kuwait?
Make the answer very short. 134.26. What is the ratio of the Emissions (1000 metric ton of CO2 equivalent) of 2000 in Korea (Republic) to that in Kuwait?
Your answer should be compact. 57.96. What is the ratio of the Emissions (1000 metric ton of CO2 equivalent) of 2005 in Korea (Republic) to that in Kuwait?
Provide a succinct answer. 44.31. What is the ratio of the Emissions (1000 metric ton of CO2 equivalent) in 2008 in Korea (Republic) to that in Kuwait?
Your response must be concise. 46.91. What is the ratio of the Emissions (1000 metric ton of CO2 equivalent) of 1990 in Korea (Republic) to that in Kyrgyz Republic?
Ensure brevity in your answer.  2.25. What is the ratio of the Emissions (1000 metric ton of CO2 equivalent) in 2000 in Korea (Republic) to that in Kyrgyz Republic?
Provide a short and direct response. 4.08. What is the ratio of the Emissions (1000 metric ton of CO2 equivalent) of 2005 in Korea (Republic) to that in Kyrgyz Republic?
Provide a short and direct response. 4.44. What is the ratio of the Emissions (1000 metric ton of CO2 equivalent) in 2008 in Korea (Republic) to that in Kyrgyz Republic?
Offer a very short reply. 4.78. What is the ratio of the Emissions (1000 metric ton of CO2 equivalent) in 1990 in Korea (Republic) to that in Latvia?
Your answer should be compact. 1.97. What is the ratio of the Emissions (1000 metric ton of CO2 equivalent) in 2000 in Korea (Republic) to that in Latvia?
Offer a very short reply. 5.54. What is the ratio of the Emissions (1000 metric ton of CO2 equivalent) in 2005 in Korea (Republic) to that in Latvia?
Provide a short and direct response. 5.02. What is the ratio of the Emissions (1000 metric ton of CO2 equivalent) of 2008 in Korea (Republic) to that in Latvia?
Provide a succinct answer. 5.31. What is the ratio of the Emissions (1000 metric ton of CO2 equivalent) in 1990 in Korea (Republic) to that in Lebanon?
Offer a terse response. 21.13. What is the ratio of the Emissions (1000 metric ton of CO2 equivalent) of 2000 in Korea (Republic) to that in Lebanon?
Your answer should be very brief. 13.79. What is the ratio of the Emissions (1000 metric ton of CO2 equivalent) of 2005 in Korea (Republic) to that in Lebanon?
Make the answer very short. 12.33. What is the ratio of the Emissions (1000 metric ton of CO2 equivalent) of 2008 in Korea (Republic) to that in Lebanon?
Your answer should be compact. 12.89. What is the ratio of the Emissions (1000 metric ton of CO2 equivalent) in 1990 in Kuwait to that in Kyrgyz Republic?
Keep it short and to the point. 0.02. What is the ratio of the Emissions (1000 metric ton of CO2 equivalent) in 2000 in Kuwait to that in Kyrgyz Republic?
Your response must be concise. 0.07. What is the ratio of the Emissions (1000 metric ton of CO2 equivalent) in 2005 in Kuwait to that in Kyrgyz Republic?
Offer a terse response. 0.1. What is the ratio of the Emissions (1000 metric ton of CO2 equivalent) of 2008 in Kuwait to that in Kyrgyz Republic?
Make the answer very short. 0.1. What is the ratio of the Emissions (1000 metric ton of CO2 equivalent) of 1990 in Kuwait to that in Latvia?
Provide a succinct answer. 0.01. What is the ratio of the Emissions (1000 metric ton of CO2 equivalent) in 2000 in Kuwait to that in Latvia?
Offer a terse response. 0.1. What is the ratio of the Emissions (1000 metric ton of CO2 equivalent) of 2005 in Kuwait to that in Latvia?
Ensure brevity in your answer.  0.11. What is the ratio of the Emissions (1000 metric ton of CO2 equivalent) of 2008 in Kuwait to that in Latvia?
Give a very brief answer. 0.11. What is the ratio of the Emissions (1000 metric ton of CO2 equivalent) of 1990 in Kuwait to that in Lebanon?
Provide a succinct answer. 0.16. What is the ratio of the Emissions (1000 metric ton of CO2 equivalent) in 2000 in Kuwait to that in Lebanon?
Offer a terse response. 0.24. What is the ratio of the Emissions (1000 metric ton of CO2 equivalent) in 2005 in Kuwait to that in Lebanon?
Provide a short and direct response. 0.28. What is the ratio of the Emissions (1000 metric ton of CO2 equivalent) in 2008 in Kuwait to that in Lebanon?
Make the answer very short. 0.27. What is the ratio of the Emissions (1000 metric ton of CO2 equivalent) of 1990 in Kyrgyz Republic to that in Latvia?
Provide a short and direct response. 0.88. What is the ratio of the Emissions (1000 metric ton of CO2 equivalent) in 2000 in Kyrgyz Republic to that in Latvia?
Make the answer very short. 1.36. What is the ratio of the Emissions (1000 metric ton of CO2 equivalent) of 2005 in Kyrgyz Republic to that in Latvia?
Offer a terse response. 1.13. What is the ratio of the Emissions (1000 metric ton of CO2 equivalent) of 2008 in Kyrgyz Republic to that in Latvia?
Your answer should be very brief. 1.11. What is the ratio of the Emissions (1000 metric ton of CO2 equivalent) in 1990 in Kyrgyz Republic to that in Lebanon?
Give a very brief answer. 9.38. What is the ratio of the Emissions (1000 metric ton of CO2 equivalent) of 2000 in Kyrgyz Republic to that in Lebanon?
Your answer should be very brief. 3.38. What is the ratio of the Emissions (1000 metric ton of CO2 equivalent) of 2005 in Kyrgyz Republic to that in Lebanon?
Provide a succinct answer. 2.78. What is the ratio of the Emissions (1000 metric ton of CO2 equivalent) of 2008 in Kyrgyz Republic to that in Lebanon?
Provide a succinct answer. 2.7. What is the ratio of the Emissions (1000 metric ton of CO2 equivalent) of 1990 in Latvia to that in Lebanon?
Keep it short and to the point. 10.71. What is the ratio of the Emissions (1000 metric ton of CO2 equivalent) of 2000 in Latvia to that in Lebanon?
Make the answer very short. 2.49. What is the ratio of the Emissions (1000 metric ton of CO2 equivalent) of 2005 in Latvia to that in Lebanon?
Provide a short and direct response. 2.46. What is the ratio of the Emissions (1000 metric ton of CO2 equivalent) of 2008 in Latvia to that in Lebanon?
Give a very brief answer. 2.43. What is the difference between the highest and the second highest Emissions (1000 metric ton of CO2 equivalent) in 1990?
Your answer should be compact. 631.3. What is the difference between the highest and the second highest Emissions (1000 metric ton of CO2 equivalent) in 2000?
Make the answer very short. 2700.4. What is the difference between the highest and the second highest Emissions (1000 metric ton of CO2 equivalent) in 2005?
Your answer should be very brief. 2734.9. What is the difference between the highest and the second highest Emissions (1000 metric ton of CO2 equivalent) in 2008?
Your response must be concise. 3202.1. What is the difference between the highest and the lowest Emissions (1000 metric ton of CO2 equivalent) of 1990?
Ensure brevity in your answer.  5522. What is the difference between the highest and the lowest Emissions (1000 metric ton of CO2 equivalent) in 2000?
Offer a terse response. 4664.9. What is the difference between the highest and the lowest Emissions (1000 metric ton of CO2 equivalent) in 2005?
Make the answer very short. 4755.2. What is the difference between the highest and the lowest Emissions (1000 metric ton of CO2 equivalent) in 2008?
Keep it short and to the point. 5274.7. 